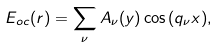Convert formula to latex. <formula><loc_0><loc_0><loc_500><loc_500>E _ { o c } ( { r } ) = \sum _ { \nu } A _ { \nu } ( y ) \cos { ( q _ { \nu } x ) } ,</formula> 